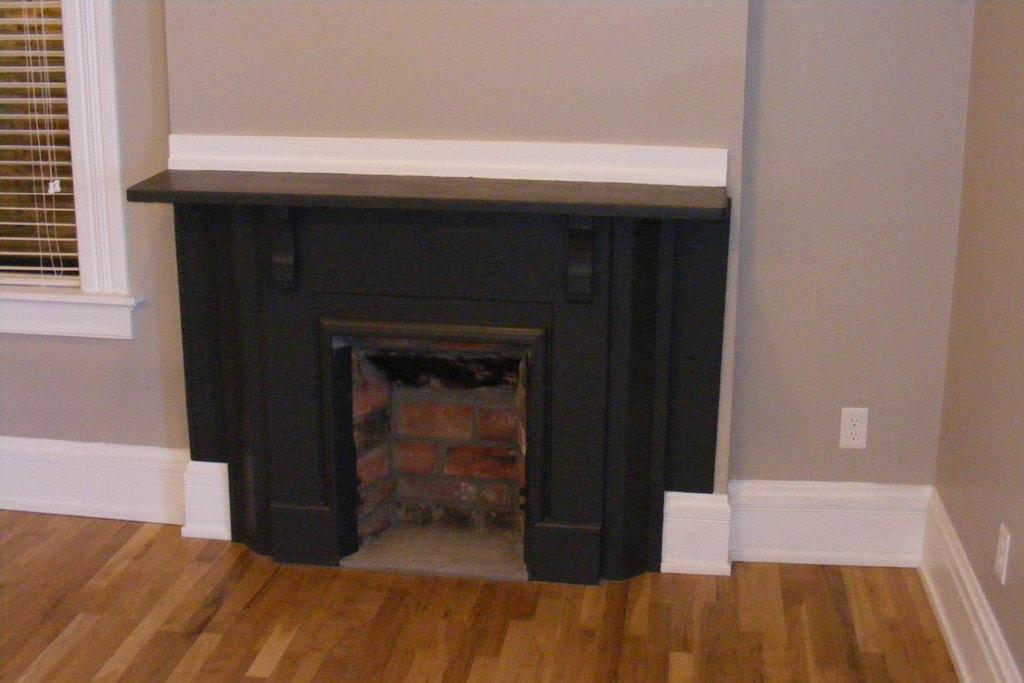Could you give a brief overview of what you see in this image? This image is taken indoors. At the bottom of the image there is a floor. In the middle of the image there is a fireplace. There are two walls with a window and a window blind. 